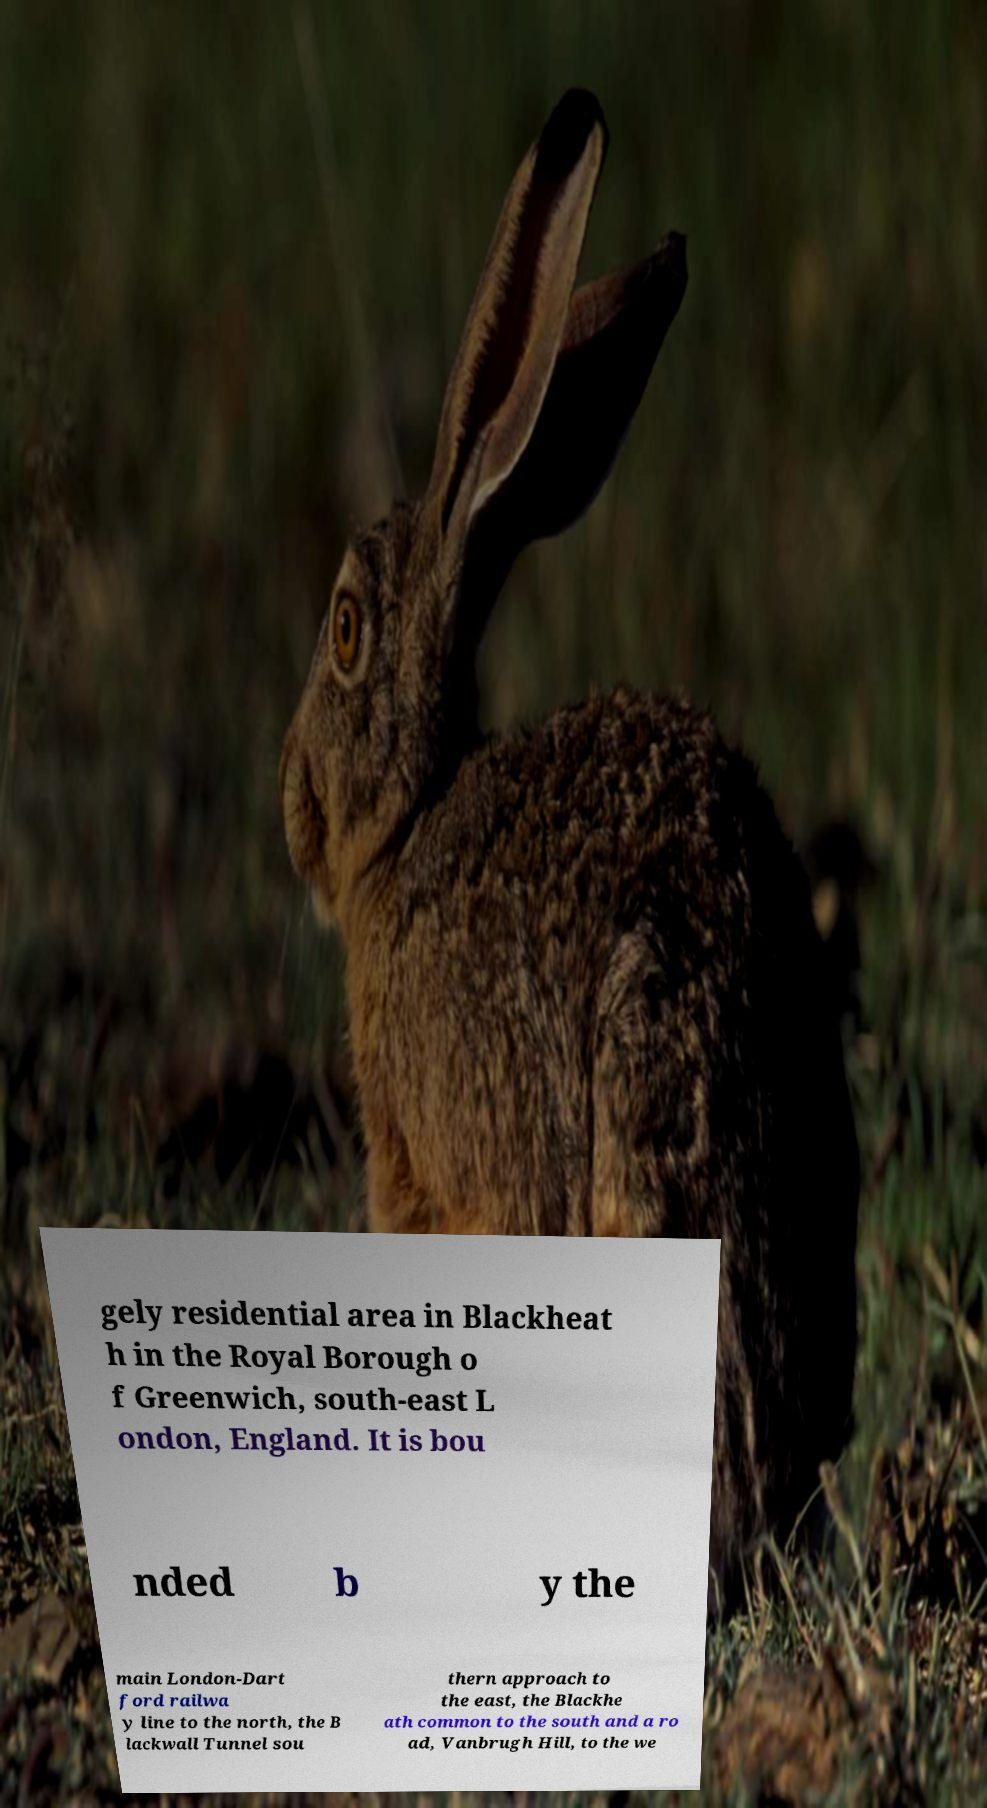Can you accurately transcribe the text from the provided image for me? gely residential area in Blackheat h in the Royal Borough o f Greenwich, south-east L ondon, England. It is bou nded b y the main London-Dart ford railwa y line to the north, the B lackwall Tunnel sou thern approach to the east, the Blackhe ath common to the south and a ro ad, Vanbrugh Hill, to the we 